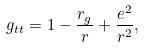Convert formula to latex. <formula><loc_0><loc_0><loc_500><loc_500>g _ { t t } = 1 - \frac { r _ { g } } { r } + \frac { e ^ { 2 } } { r ^ { 2 } } ,</formula> 